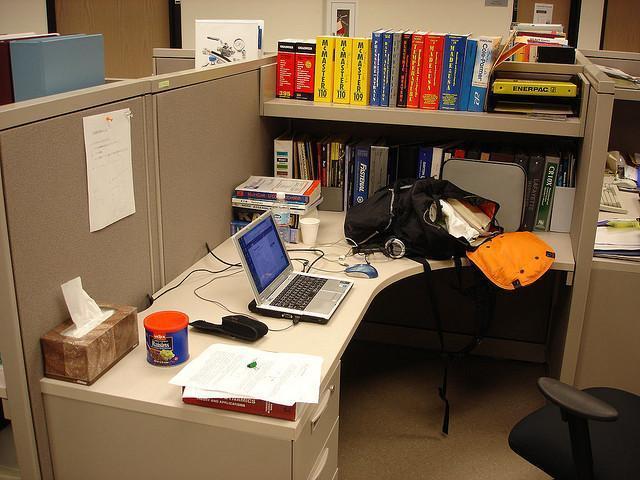How many people were sitting here?
Give a very brief answer. 1. 